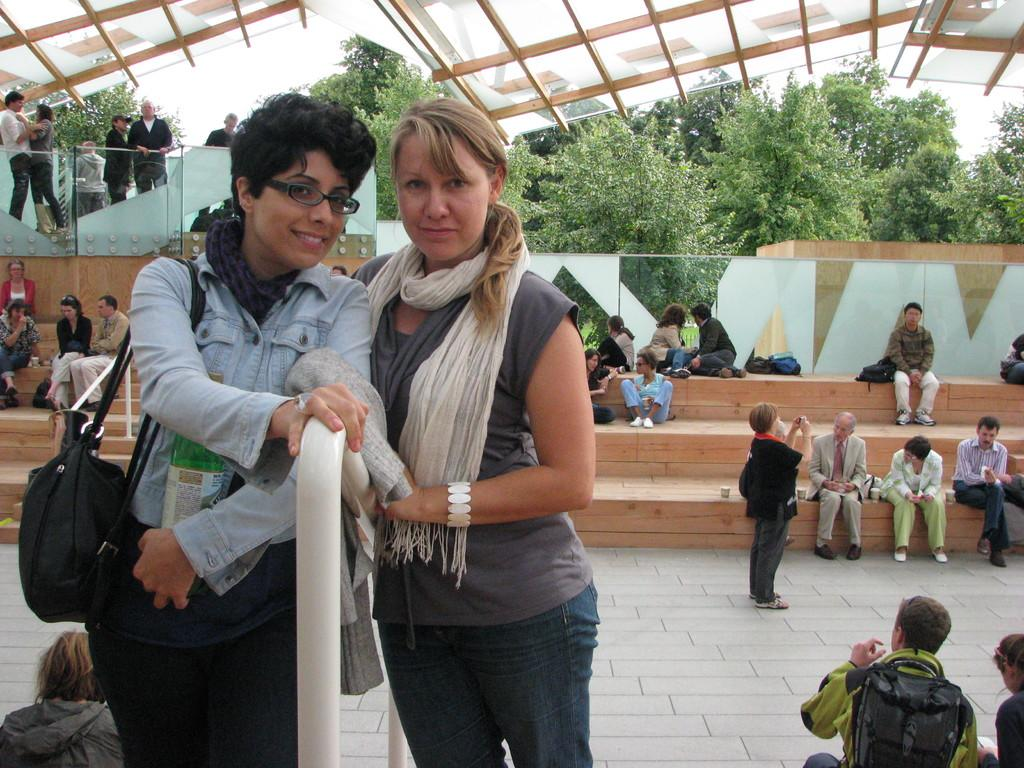What is the main subject of the image? The main subject of the image is groups of people. What are some of the people in the image doing? Some people are standing, and some are sitting. What can be seen in the background of the image? There are trees and the sky visible in the background of the image. What type of sand can be seen on the floor in the image? There is no sand or floor present in the image; it features groups of people with a background of trees and the sky. What is the color of the tongue of the person in the image? There is no person's tongue visible in the image. 